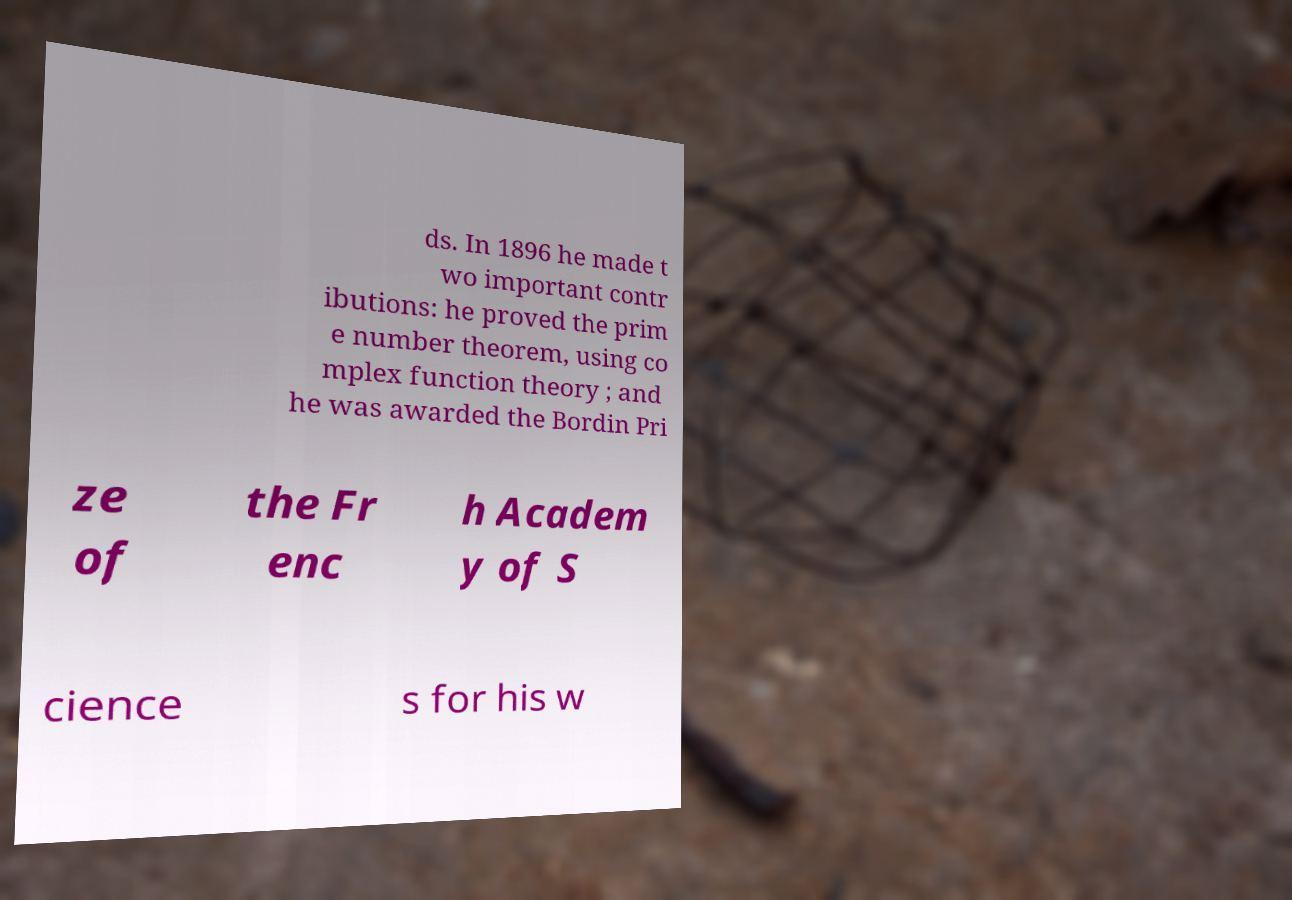Can you accurately transcribe the text from the provided image for me? ds. In 1896 he made t wo important contr ibutions: he proved the prim e number theorem, using co mplex function theory ; and he was awarded the Bordin Pri ze of the Fr enc h Academ y of S cience s for his w 